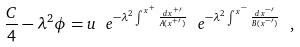Convert formula to latex. <formula><loc_0><loc_0><loc_500><loc_500>\frac { C } { 4 } - \lambda ^ { 2 } \phi = u \ e ^ { - \lambda ^ { 2 } \int ^ { x ^ { + } } \frac { d x ^ { + \prime } } { A ( x ^ { + \prime } ) } } \ e ^ { - \lambda ^ { 2 } \int ^ { x ^ { - } } \frac { d x ^ { - \prime } } { B ( x ^ { - \prime } ) } } \ ,</formula> 